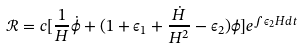<formula> <loc_0><loc_0><loc_500><loc_500>\mathcal { R } = c [ \frac { 1 } { H } \dot { \phi } + ( 1 + \epsilon _ { 1 } + \frac { \dot { H } } { H ^ { 2 } } - \epsilon _ { 2 } ) \phi ] e ^ { \int \epsilon _ { 2 } H d t }</formula> 